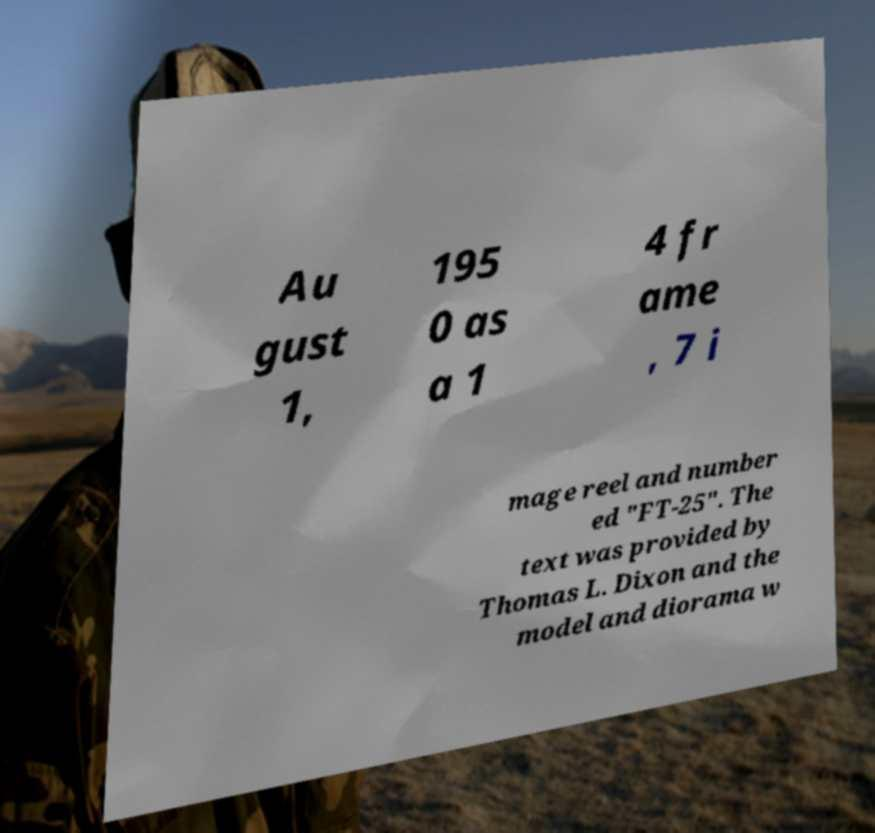Please identify and transcribe the text found in this image. Au gust 1, 195 0 as a 1 4 fr ame , 7 i mage reel and number ed "FT-25". The text was provided by Thomas L. Dixon and the model and diorama w 